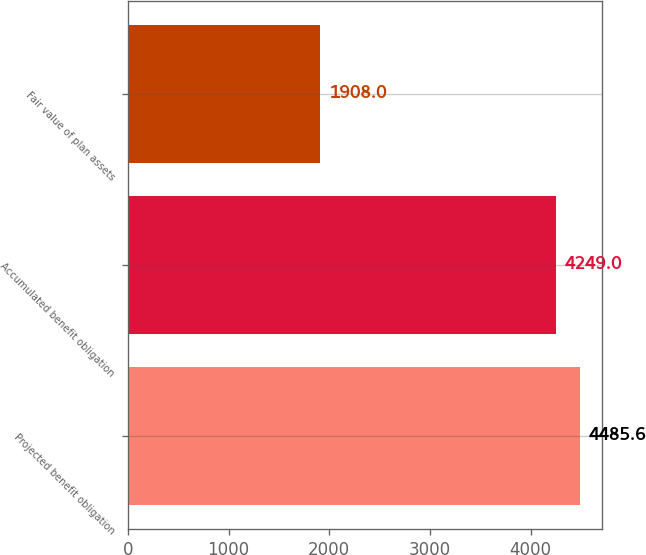Convert chart. <chart><loc_0><loc_0><loc_500><loc_500><bar_chart><fcel>Projected benefit obligation<fcel>Accumulated benefit obligation<fcel>Fair value of plan assets<nl><fcel>4485.6<fcel>4249<fcel>1908<nl></chart> 